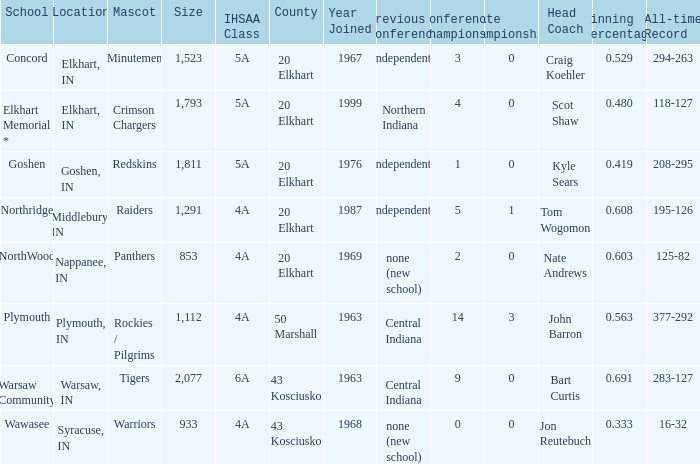What country joined before 1976, with IHSSA class of 5a, and a size larger than 1,112? 20 Elkhart. 